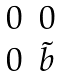Convert formula to latex. <formula><loc_0><loc_0><loc_500><loc_500>\begin{matrix} 0 & 0 \\ 0 & \tilde { b } \end{matrix}</formula> 